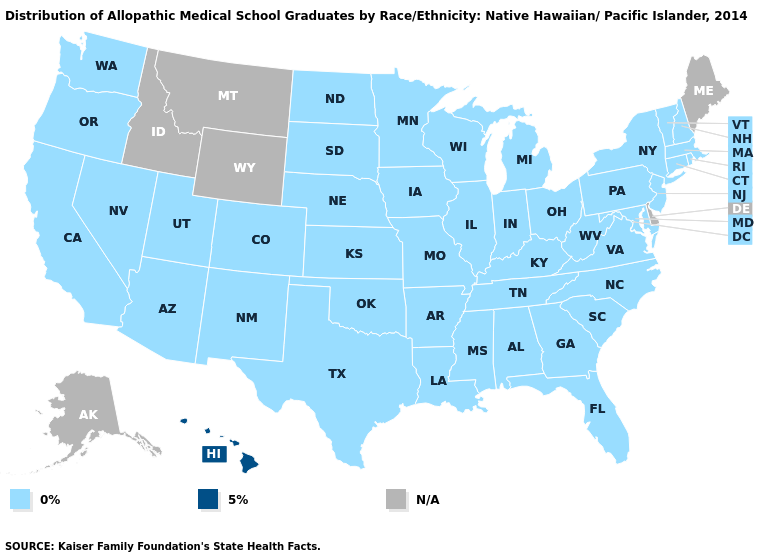How many symbols are there in the legend?
Quick response, please. 3. Among the states that border Tennessee , which have the lowest value?
Write a very short answer. Alabama, Arkansas, Georgia, Kentucky, Mississippi, Missouri, North Carolina, Virginia. What is the value of Missouri?
Concise answer only. 0%. What is the highest value in the USA?
Write a very short answer. 5%. Among the states that border Pennsylvania , which have the highest value?
Keep it brief. Maryland, New Jersey, New York, Ohio, West Virginia. Name the states that have a value in the range 5%?
Quick response, please. Hawaii. What is the value of Georgia?
Give a very brief answer. 0%. Name the states that have a value in the range 5%?
Concise answer only. Hawaii. What is the lowest value in the USA?
Keep it brief. 0%. What is the highest value in states that border Louisiana?
Give a very brief answer. 0%. What is the value of Maryland?
Give a very brief answer. 0%. What is the value of Illinois?
Be succinct. 0%. What is the value of New Jersey?
Write a very short answer. 0%. What is the value of New Mexico?
Quick response, please. 0%. 